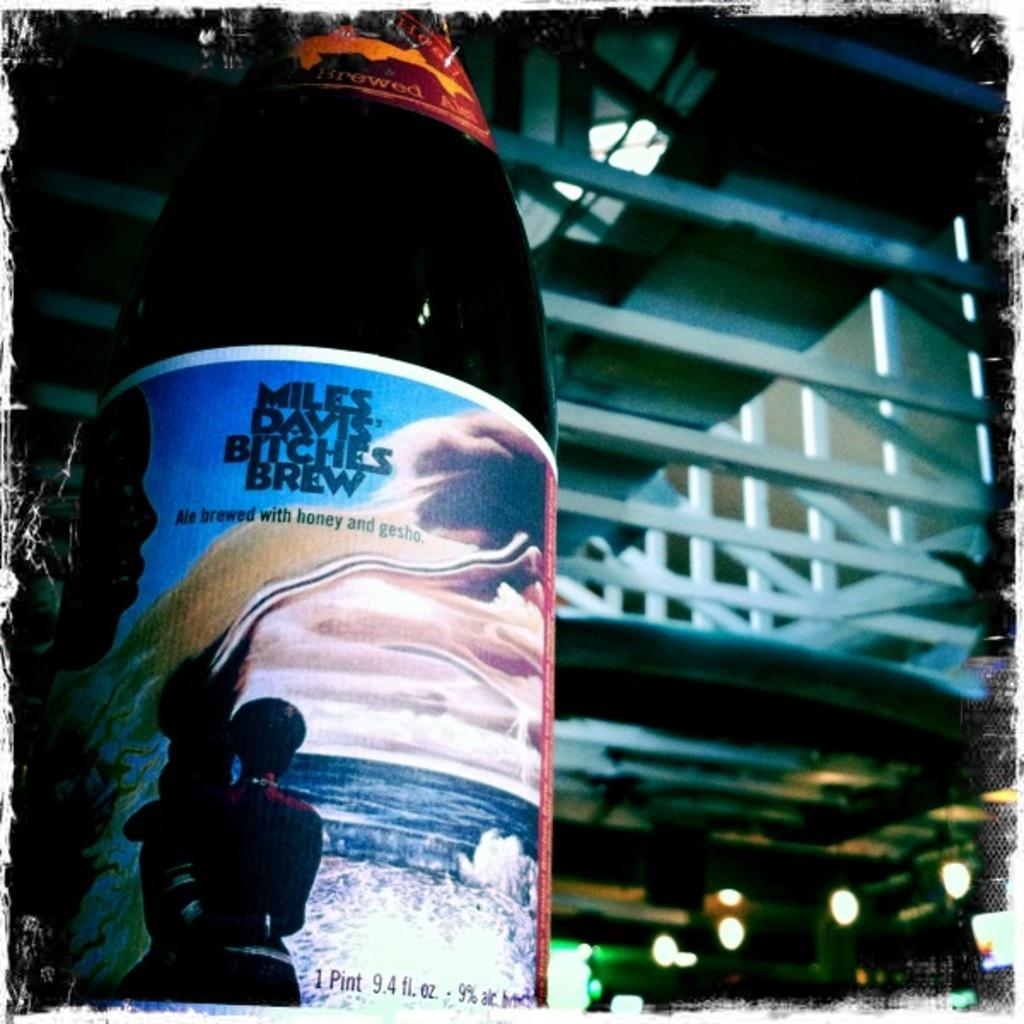<image>
Offer a succinct explanation of the picture presented. A bottle with Miles Davis Bitches Brew on the label with an seascape illustration of a person looking out towards sea. 